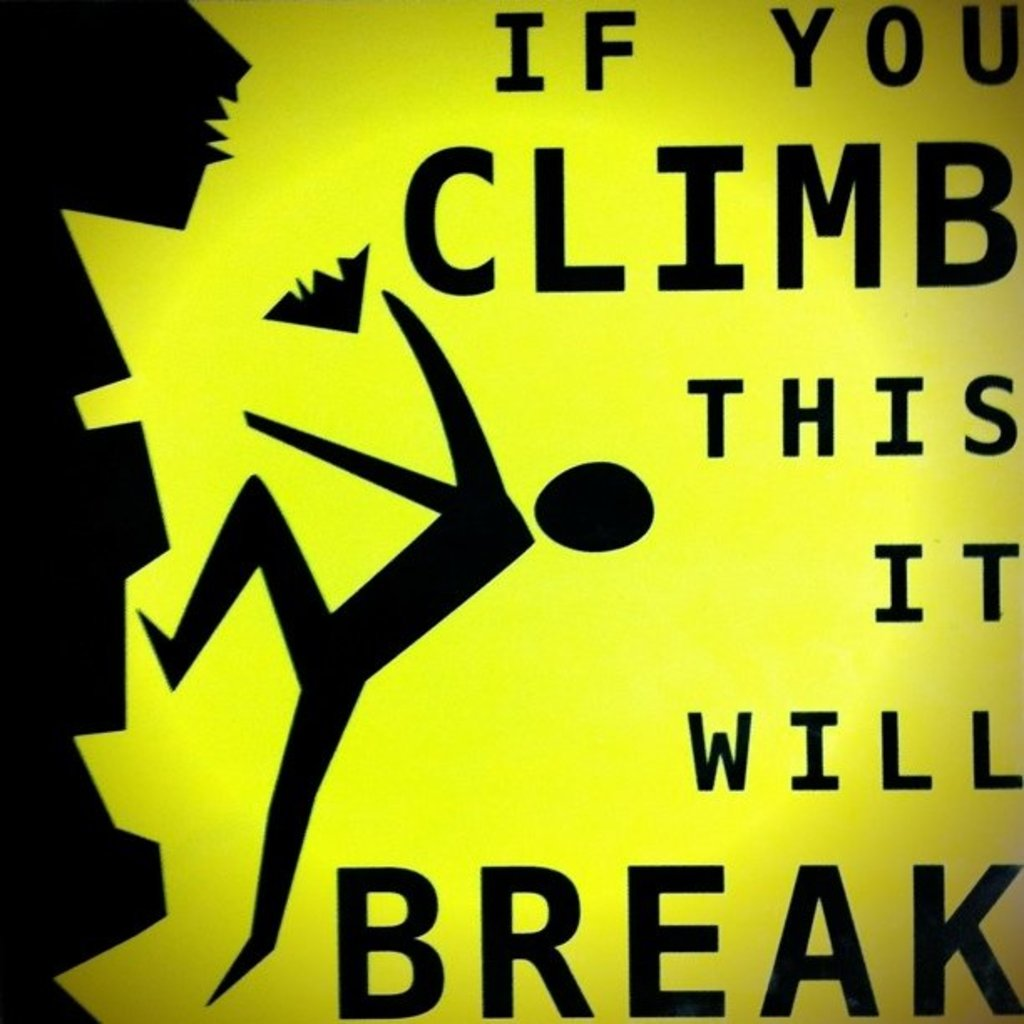Why is it important to use such graphical warnings in safety signs? Graphical warnings are crucial because they convey the message quickly and effectively to people of all ages and backgrounds, even those who may not speak the local language fluently. The use of universal symbols, such as the figure climbing and the broken part of the structure, immediately communicates the danger and what actions to avoid. This visual immediacy is essential in safety signs to prevent accidents and ensure that the warning reaches as broad an audience as possible. 